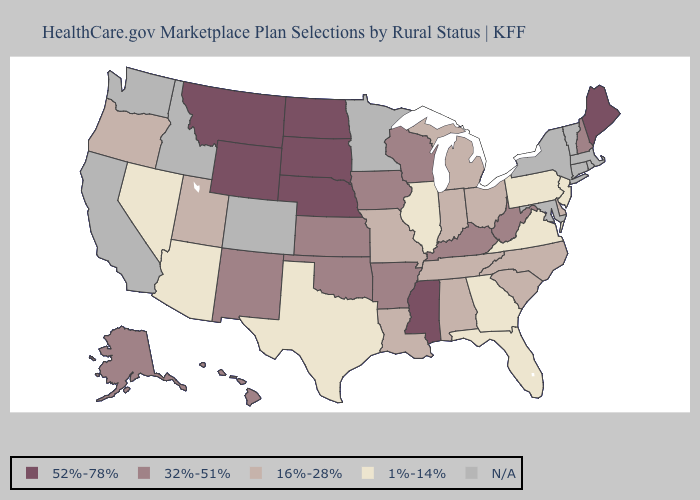What is the value of Arizona?
Quick response, please. 1%-14%. Does Arkansas have the lowest value in the USA?
Keep it brief. No. Name the states that have a value in the range 16%-28%?
Answer briefly. Alabama, Delaware, Indiana, Louisiana, Michigan, Missouri, North Carolina, Ohio, Oregon, South Carolina, Tennessee, Utah. Name the states that have a value in the range N/A?
Keep it brief. California, Colorado, Connecticut, Idaho, Maryland, Massachusetts, Minnesota, New York, Rhode Island, Vermont, Washington. Does New Mexico have the lowest value in the West?
Short answer required. No. Name the states that have a value in the range 52%-78%?
Write a very short answer. Maine, Mississippi, Montana, Nebraska, North Dakota, South Dakota, Wyoming. Does Illinois have the lowest value in the USA?
Quick response, please. Yes. Name the states that have a value in the range N/A?
Give a very brief answer. California, Colorado, Connecticut, Idaho, Maryland, Massachusetts, Minnesota, New York, Rhode Island, Vermont, Washington. Name the states that have a value in the range 52%-78%?
Short answer required. Maine, Mississippi, Montana, Nebraska, North Dakota, South Dakota, Wyoming. Which states have the lowest value in the USA?
Answer briefly. Arizona, Florida, Georgia, Illinois, Nevada, New Jersey, Pennsylvania, Texas, Virginia. Does Georgia have the lowest value in the USA?
Write a very short answer. Yes. Among the states that border New York , which have the lowest value?
Be succinct. New Jersey, Pennsylvania. Name the states that have a value in the range 32%-51%?
Keep it brief. Alaska, Arkansas, Hawaii, Iowa, Kansas, Kentucky, New Hampshire, New Mexico, Oklahoma, West Virginia, Wisconsin. Does the first symbol in the legend represent the smallest category?
Quick response, please. No. 